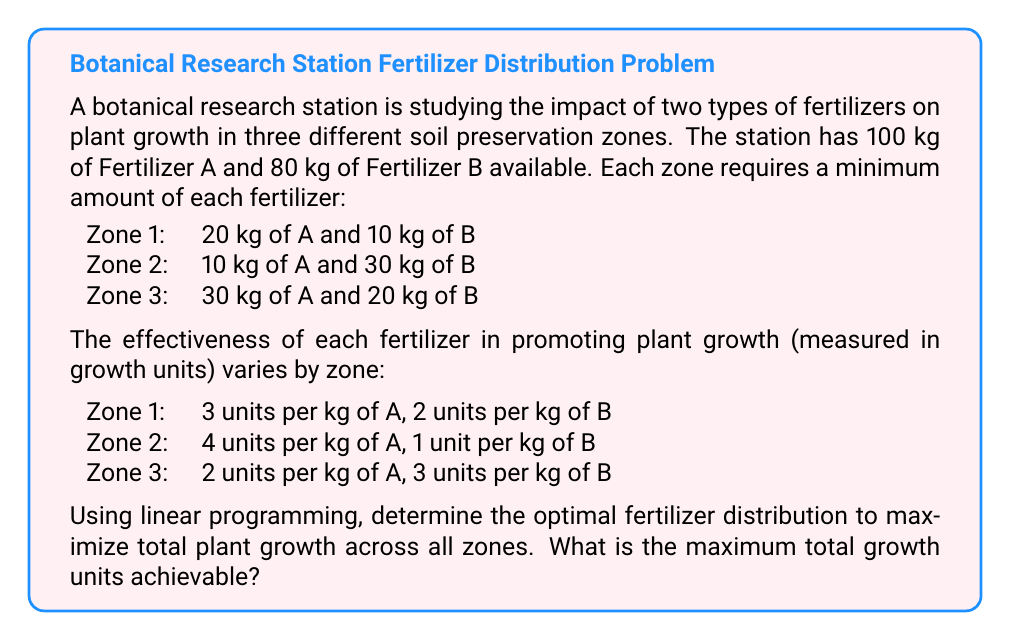Can you solve this math problem? To solve this problem, we'll use linear programming techniques. Let's define our variables and set up the linear program:

Let $x_1$, $x_2$, and $x_3$ be the amount of Fertilizer A used in Zones 1, 2, and 3 respectively.
Let $y_1$, $y_2$, and $y_3$ be the amount of Fertilizer B used in Zones 1, 2, and 3 respectively.

Objective function (maximize total growth units):
$$\text{Maximize } Z = 3x_1 + 2y_1 + 4x_2 + y_2 + 2x_3 + 3y_3$$

Constraints:
1. Total Fertilizer A: $x_1 + x_2 + x_3 \leq 100$
2. Total Fertilizer B: $y_1 + y_2 + y_3 \leq 80$
3. Minimum requirements for each zone:
   Zone 1: $x_1 \geq 20$, $y_1 \geq 10$
   Zone 2: $x_2 \geq 10$, $y_2 \geq 30$
   Zone 3: $x_3 \geq 30$, $y_3 \geq 20$
4. Non-negativity: $x_1, x_2, x_3, y_1, y_2, y_3 \geq 0$

To solve this linear program, we can use the simplex method or a linear programming solver. The optimal solution is:

$x_1 = 20$, $y_1 = 10$
$x_2 = 50$, $y_2 = 30$
$x_3 = 30$, $y_3 = 40$

Substituting these values into the objective function:

$Z = 3(20) + 2(10) + 4(50) + 1(30) + 2(30) + 3(40)$
$Z = 60 + 20 + 200 + 30 + 60 + 120$
$Z = 490$

Therefore, the maximum total growth units achievable is 490.
Answer: 490 growth units 